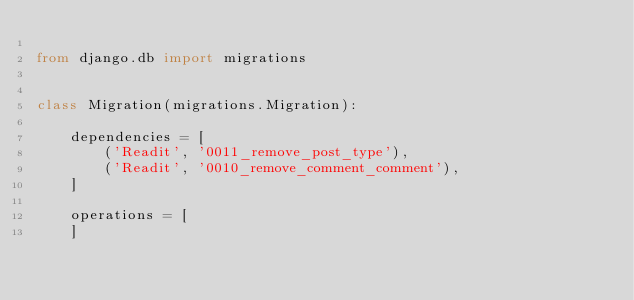<code> <loc_0><loc_0><loc_500><loc_500><_Python_>
from django.db import migrations


class Migration(migrations.Migration):

    dependencies = [
        ('Readit', '0011_remove_post_type'),
        ('Readit', '0010_remove_comment_comment'),
    ]

    operations = [
    ]
</code> 